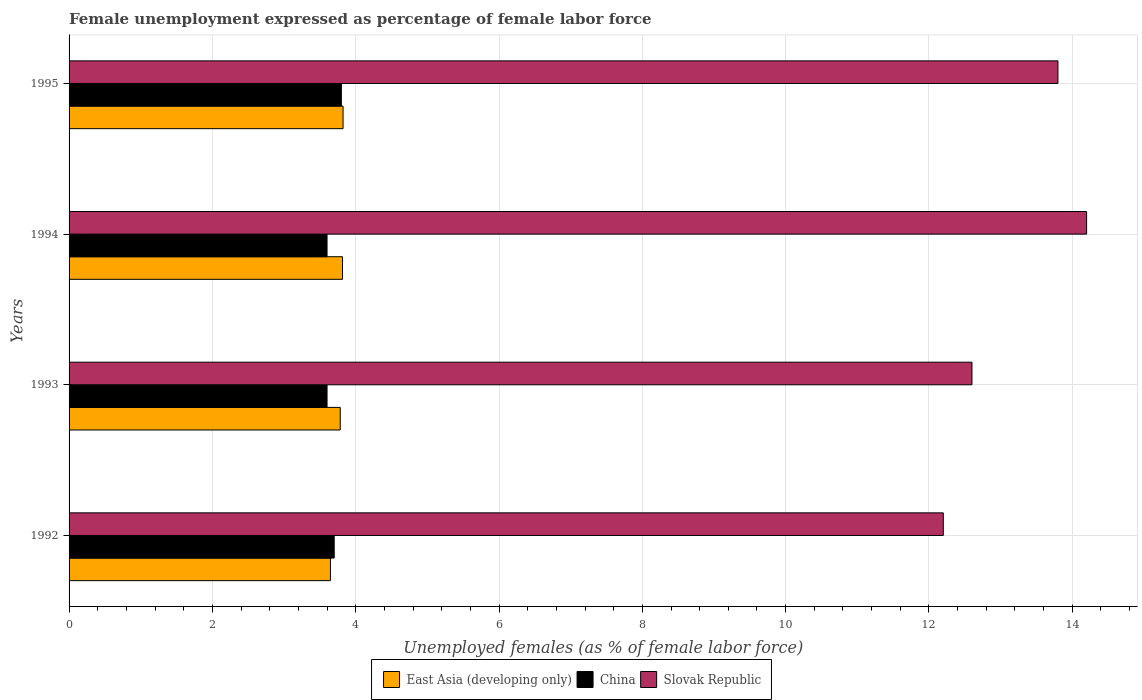How many different coloured bars are there?
Keep it short and to the point. 3. How many groups of bars are there?
Make the answer very short. 4. Are the number of bars per tick equal to the number of legend labels?
Provide a succinct answer. Yes. How many bars are there on the 2nd tick from the top?
Offer a terse response. 3. What is the unemployment in females in in Slovak Republic in 1992?
Provide a succinct answer. 12.2. Across all years, what is the maximum unemployment in females in in China?
Ensure brevity in your answer.  3.8. Across all years, what is the minimum unemployment in females in in East Asia (developing only)?
Offer a very short reply. 3.65. In which year was the unemployment in females in in East Asia (developing only) maximum?
Make the answer very short. 1995. In which year was the unemployment in females in in Slovak Republic minimum?
Provide a succinct answer. 1992. What is the total unemployment in females in in Slovak Republic in the graph?
Offer a very short reply. 52.8. What is the difference between the unemployment in females in in Slovak Republic in 1993 and that in 1995?
Keep it short and to the point. -1.2. What is the difference between the unemployment in females in in Slovak Republic in 1993 and the unemployment in females in in China in 1992?
Provide a short and direct response. 8.9. What is the average unemployment in females in in China per year?
Keep it short and to the point. 3.67. In the year 1995, what is the difference between the unemployment in females in in China and unemployment in females in in East Asia (developing only)?
Provide a short and direct response. -0.02. What is the ratio of the unemployment in females in in China in 1992 to that in 1994?
Keep it short and to the point. 1.03. Is the difference between the unemployment in females in in China in 1992 and 1995 greater than the difference between the unemployment in females in in East Asia (developing only) in 1992 and 1995?
Keep it short and to the point. Yes. What is the difference between the highest and the second highest unemployment in females in in East Asia (developing only)?
Give a very brief answer. 0.01. What is the difference between the highest and the lowest unemployment in females in in East Asia (developing only)?
Offer a terse response. 0.18. Is the sum of the unemployment in females in in China in 1993 and 1994 greater than the maximum unemployment in females in in Slovak Republic across all years?
Offer a terse response. No. What does the 1st bar from the top in 1995 represents?
Your response must be concise. Slovak Republic. How many bars are there?
Ensure brevity in your answer.  12. How many years are there in the graph?
Your answer should be compact. 4. What is the difference between two consecutive major ticks on the X-axis?
Keep it short and to the point. 2. Are the values on the major ticks of X-axis written in scientific E-notation?
Keep it short and to the point. No. Does the graph contain any zero values?
Keep it short and to the point. No. Where does the legend appear in the graph?
Offer a very short reply. Bottom center. What is the title of the graph?
Give a very brief answer. Female unemployment expressed as percentage of female labor force. Does "Turks and Caicos Islands" appear as one of the legend labels in the graph?
Keep it short and to the point. No. What is the label or title of the X-axis?
Your response must be concise. Unemployed females (as % of female labor force). What is the label or title of the Y-axis?
Your response must be concise. Years. What is the Unemployed females (as % of female labor force) in East Asia (developing only) in 1992?
Make the answer very short. 3.65. What is the Unemployed females (as % of female labor force) of China in 1992?
Your response must be concise. 3.7. What is the Unemployed females (as % of female labor force) of Slovak Republic in 1992?
Give a very brief answer. 12.2. What is the Unemployed females (as % of female labor force) in East Asia (developing only) in 1993?
Your answer should be compact. 3.78. What is the Unemployed females (as % of female labor force) of China in 1993?
Offer a very short reply. 3.6. What is the Unemployed females (as % of female labor force) in Slovak Republic in 1993?
Offer a terse response. 12.6. What is the Unemployed females (as % of female labor force) in East Asia (developing only) in 1994?
Keep it short and to the point. 3.82. What is the Unemployed females (as % of female labor force) of China in 1994?
Ensure brevity in your answer.  3.6. What is the Unemployed females (as % of female labor force) of Slovak Republic in 1994?
Offer a very short reply. 14.2. What is the Unemployed females (as % of female labor force) in East Asia (developing only) in 1995?
Give a very brief answer. 3.82. What is the Unemployed females (as % of female labor force) of China in 1995?
Offer a terse response. 3.8. What is the Unemployed females (as % of female labor force) of Slovak Republic in 1995?
Keep it short and to the point. 13.8. Across all years, what is the maximum Unemployed females (as % of female labor force) of East Asia (developing only)?
Make the answer very short. 3.82. Across all years, what is the maximum Unemployed females (as % of female labor force) of China?
Your response must be concise. 3.8. Across all years, what is the maximum Unemployed females (as % of female labor force) in Slovak Republic?
Keep it short and to the point. 14.2. Across all years, what is the minimum Unemployed females (as % of female labor force) of East Asia (developing only)?
Offer a very short reply. 3.65. Across all years, what is the minimum Unemployed females (as % of female labor force) in China?
Your answer should be compact. 3.6. Across all years, what is the minimum Unemployed females (as % of female labor force) in Slovak Republic?
Give a very brief answer. 12.2. What is the total Unemployed females (as % of female labor force) in East Asia (developing only) in the graph?
Make the answer very short. 15.07. What is the total Unemployed females (as % of female labor force) in China in the graph?
Provide a short and direct response. 14.7. What is the total Unemployed females (as % of female labor force) of Slovak Republic in the graph?
Offer a very short reply. 52.8. What is the difference between the Unemployed females (as % of female labor force) of East Asia (developing only) in 1992 and that in 1993?
Provide a short and direct response. -0.14. What is the difference between the Unemployed females (as % of female labor force) of China in 1992 and that in 1993?
Provide a succinct answer. 0.1. What is the difference between the Unemployed females (as % of female labor force) in Slovak Republic in 1992 and that in 1993?
Offer a very short reply. -0.4. What is the difference between the Unemployed females (as % of female labor force) of East Asia (developing only) in 1992 and that in 1994?
Provide a short and direct response. -0.17. What is the difference between the Unemployed females (as % of female labor force) of East Asia (developing only) in 1992 and that in 1995?
Provide a short and direct response. -0.18. What is the difference between the Unemployed females (as % of female labor force) in Slovak Republic in 1992 and that in 1995?
Your answer should be compact. -1.6. What is the difference between the Unemployed females (as % of female labor force) in East Asia (developing only) in 1993 and that in 1994?
Ensure brevity in your answer.  -0.03. What is the difference between the Unemployed females (as % of female labor force) of Slovak Republic in 1993 and that in 1994?
Ensure brevity in your answer.  -1.6. What is the difference between the Unemployed females (as % of female labor force) of East Asia (developing only) in 1993 and that in 1995?
Your answer should be compact. -0.04. What is the difference between the Unemployed females (as % of female labor force) in Slovak Republic in 1993 and that in 1995?
Your answer should be very brief. -1.2. What is the difference between the Unemployed females (as % of female labor force) of East Asia (developing only) in 1994 and that in 1995?
Keep it short and to the point. -0.01. What is the difference between the Unemployed females (as % of female labor force) in China in 1994 and that in 1995?
Offer a terse response. -0.2. What is the difference between the Unemployed females (as % of female labor force) in East Asia (developing only) in 1992 and the Unemployed females (as % of female labor force) in China in 1993?
Offer a terse response. 0.05. What is the difference between the Unemployed females (as % of female labor force) of East Asia (developing only) in 1992 and the Unemployed females (as % of female labor force) of Slovak Republic in 1993?
Provide a succinct answer. -8.95. What is the difference between the Unemployed females (as % of female labor force) of China in 1992 and the Unemployed females (as % of female labor force) of Slovak Republic in 1993?
Give a very brief answer. -8.9. What is the difference between the Unemployed females (as % of female labor force) of East Asia (developing only) in 1992 and the Unemployed females (as % of female labor force) of China in 1994?
Make the answer very short. 0.05. What is the difference between the Unemployed females (as % of female labor force) in East Asia (developing only) in 1992 and the Unemployed females (as % of female labor force) in Slovak Republic in 1994?
Make the answer very short. -10.55. What is the difference between the Unemployed females (as % of female labor force) in East Asia (developing only) in 1992 and the Unemployed females (as % of female labor force) in China in 1995?
Ensure brevity in your answer.  -0.15. What is the difference between the Unemployed females (as % of female labor force) of East Asia (developing only) in 1992 and the Unemployed females (as % of female labor force) of Slovak Republic in 1995?
Provide a short and direct response. -10.15. What is the difference between the Unemployed females (as % of female labor force) in East Asia (developing only) in 1993 and the Unemployed females (as % of female labor force) in China in 1994?
Provide a short and direct response. 0.18. What is the difference between the Unemployed females (as % of female labor force) of East Asia (developing only) in 1993 and the Unemployed females (as % of female labor force) of Slovak Republic in 1994?
Give a very brief answer. -10.42. What is the difference between the Unemployed females (as % of female labor force) of East Asia (developing only) in 1993 and the Unemployed females (as % of female labor force) of China in 1995?
Your answer should be very brief. -0.02. What is the difference between the Unemployed females (as % of female labor force) in East Asia (developing only) in 1993 and the Unemployed females (as % of female labor force) in Slovak Republic in 1995?
Offer a very short reply. -10.02. What is the difference between the Unemployed females (as % of female labor force) of China in 1993 and the Unemployed females (as % of female labor force) of Slovak Republic in 1995?
Your answer should be very brief. -10.2. What is the difference between the Unemployed females (as % of female labor force) in East Asia (developing only) in 1994 and the Unemployed females (as % of female labor force) in China in 1995?
Your response must be concise. 0.02. What is the difference between the Unemployed females (as % of female labor force) of East Asia (developing only) in 1994 and the Unemployed females (as % of female labor force) of Slovak Republic in 1995?
Your response must be concise. -9.98. What is the average Unemployed females (as % of female labor force) in East Asia (developing only) per year?
Offer a very short reply. 3.77. What is the average Unemployed females (as % of female labor force) in China per year?
Provide a short and direct response. 3.67. In the year 1992, what is the difference between the Unemployed females (as % of female labor force) in East Asia (developing only) and Unemployed females (as % of female labor force) in China?
Offer a very short reply. -0.05. In the year 1992, what is the difference between the Unemployed females (as % of female labor force) of East Asia (developing only) and Unemployed females (as % of female labor force) of Slovak Republic?
Your answer should be very brief. -8.55. In the year 1992, what is the difference between the Unemployed females (as % of female labor force) in China and Unemployed females (as % of female labor force) in Slovak Republic?
Provide a succinct answer. -8.5. In the year 1993, what is the difference between the Unemployed females (as % of female labor force) in East Asia (developing only) and Unemployed females (as % of female labor force) in China?
Keep it short and to the point. 0.18. In the year 1993, what is the difference between the Unemployed females (as % of female labor force) in East Asia (developing only) and Unemployed females (as % of female labor force) in Slovak Republic?
Keep it short and to the point. -8.82. In the year 1993, what is the difference between the Unemployed females (as % of female labor force) of China and Unemployed females (as % of female labor force) of Slovak Republic?
Make the answer very short. -9. In the year 1994, what is the difference between the Unemployed females (as % of female labor force) of East Asia (developing only) and Unemployed females (as % of female labor force) of China?
Offer a terse response. 0.22. In the year 1994, what is the difference between the Unemployed females (as % of female labor force) of East Asia (developing only) and Unemployed females (as % of female labor force) of Slovak Republic?
Your answer should be compact. -10.38. In the year 1994, what is the difference between the Unemployed females (as % of female labor force) of China and Unemployed females (as % of female labor force) of Slovak Republic?
Give a very brief answer. -10.6. In the year 1995, what is the difference between the Unemployed females (as % of female labor force) in East Asia (developing only) and Unemployed females (as % of female labor force) in China?
Your response must be concise. 0.02. In the year 1995, what is the difference between the Unemployed females (as % of female labor force) of East Asia (developing only) and Unemployed females (as % of female labor force) of Slovak Republic?
Give a very brief answer. -9.98. What is the ratio of the Unemployed females (as % of female labor force) of East Asia (developing only) in 1992 to that in 1993?
Offer a very short reply. 0.96. What is the ratio of the Unemployed females (as % of female labor force) in China in 1992 to that in 1993?
Offer a terse response. 1.03. What is the ratio of the Unemployed females (as % of female labor force) in Slovak Republic in 1992 to that in 1993?
Ensure brevity in your answer.  0.97. What is the ratio of the Unemployed females (as % of female labor force) in East Asia (developing only) in 1992 to that in 1994?
Make the answer very short. 0.96. What is the ratio of the Unemployed females (as % of female labor force) of China in 1992 to that in 1994?
Your response must be concise. 1.03. What is the ratio of the Unemployed females (as % of female labor force) of Slovak Republic in 1992 to that in 1994?
Provide a succinct answer. 0.86. What is the ratio of the Unemployed females (as % of female labor force) of East Asia (developing only) in 1992 to that in 1995?
Give a very brief answer. 0.95. What is the ratio of the Unemployed females (as % of female labor force) of China in 1992 to that in 1995?
Your answer should be very brief. 0.97. What is the ratio of the Unemployed females (as % of female labor force) of Slovak Republic in 1992 to that in 1995?
Offer a very short reply. 0.88. What is the ratio of the Unemployed females (as % of female labor force) in China in 1993 to that in 1994?
Your response must be concise. 1. What is the ratio of the Unemployed females (as % of female labor force) of Slovak Republic in 1993 to that in 1994?
Offer a very short reply. 0.89. What is the ratio of the Unemployed females (as % of female labor force) in East Asia (developing only) in 1993 to that in 1995?
Offer a terse response. 0.99. What is the ratio of the Unemployed females (as % of female labor force) of China in 1993 to that in 1995?
Provide a short and direct response. 0.95. What is the ratio of the Unemployed females (as % of female labor force) in Slovak Republic in 1993 to that in 1995?
Keep it short and to the point. 0.91. What is the ratio of the Unemployed females (as % of female labor force) in East Asia (developing only) in 1994 to that in 1995?
Give a very brief answer. 1. What is the difference between the highest and the second highest Unemployed females (as % of female labor force) of East Asia (developing only)?
Give a very brief answer. 0.01. What is the difference between the highest and the second highest Unemployed females (as % of female labor force) of China?
Make the answer very short. 0.1. What is the difference between the highest and the second highest Unemployed females (as % of female labor force) in Slovak Republic?
Provide a succinct answer. 0.4. What is the difference between the highest and the lowest Unemployed females (as % of female labor force) in East Asia (developing only)?
Ensure brevity in your answer.  0.18. What is the difference between the highest and the lowest Unemployed females (as % of female labor force) of China?
Offer a terse response. 0.2. What is the difference between the highest and the lowest Unemployed females (as % of female labor force) in Slovak Republic?
Your answer should be compact. 2. 